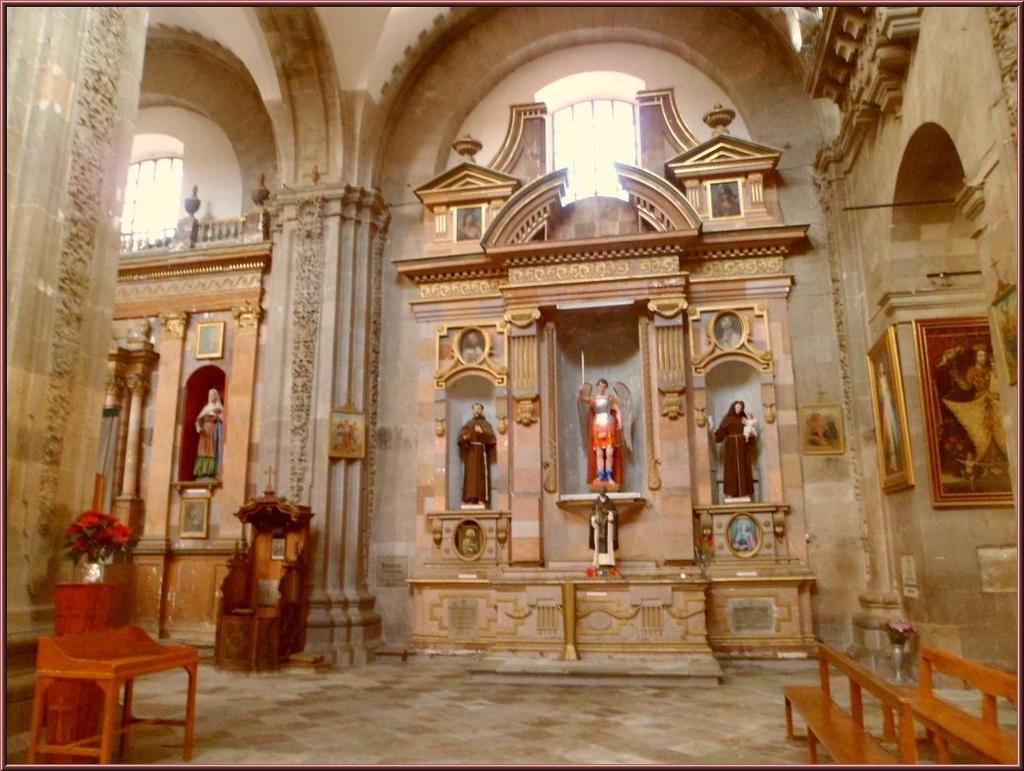Describe this image in one or two sentences. This is an inside view of a building and here we can see statues, some frames on the wall and there are stands, benches, flower vases. At the bottom, there is a floor. 